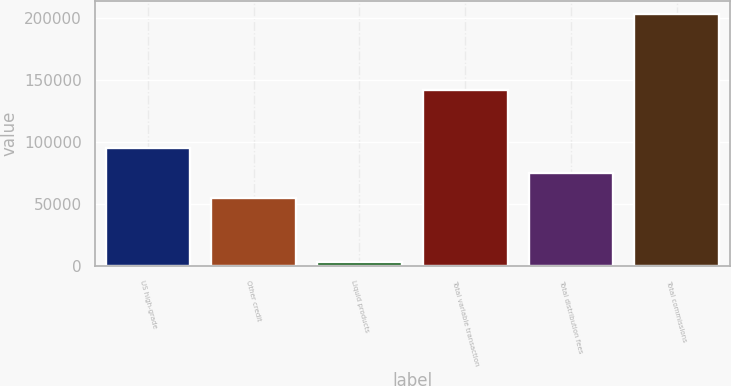<chart> <loc_0><loc_0><loc_500><loc_500><bar_chart><fcel>US high-grade<fcel>Other credit<fcel>Liquid products<fcel>Total variable transaction<fcel>Total distribution fees<fcel>Total commissions<nl><fcel>95090.4<fcel>55046<fcel>3430<fcel>142293<fcel>75068.2<fcel>203652<nl></chart> 